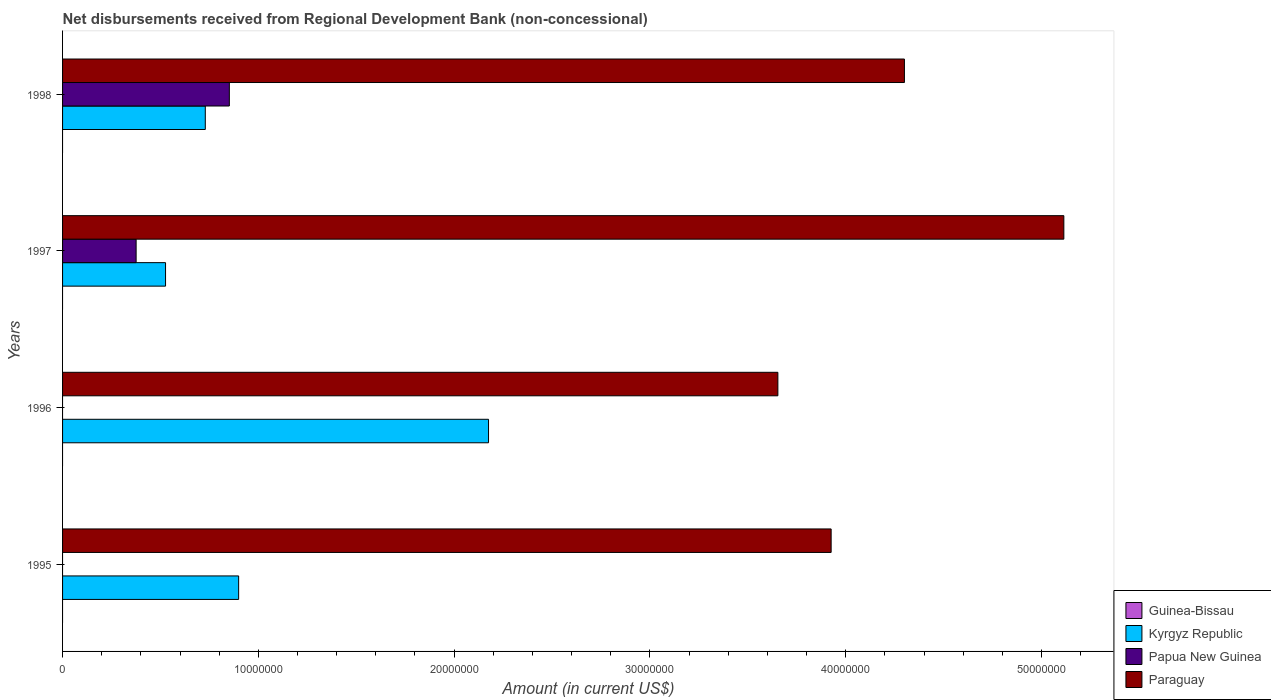How many groups of bars are there?
Ensure brevity in your answer.  4. Are the number of bars per tick equal to the number of legend labels?
Your answer should be very brief. No. In how many cases, is the number of bars for a given year not equal to the number of legend labels?
Your response must be concise. 4. What is the amount of disbursements received from Regional Development Bank in Guinea-Bissau in 1996?
Make the answer very short. 0. Across all years, what is the maximum amount of disbursements received from Regional Development Bank in Paraguay?
Provide a short and direct response. 5.11e+07. Across all years, what is the minimum amount of disbursements received from Regional Development Bank in Kyrgyz Republic?
Offer a very short reply. 5.26e+06. In which year was the amount of disbursements received from Regional Development Bank in Kyrgyz Republic maximum?
Your response must be concise. 1996. What is the total amount of disbursements received from Regional Development Bank in Kyrgyz Republic in the graph?
Provide a short and direct response. 4.33e+07. What is the difference between the amount of disbursements received from Regional Development Bank in Paraguay in 1995 and that in 1997?
Make the answer very short. -1.19e+07. What is the difference between the amount of disbursements received from Regional Development Bank in Paraguay in 1998 and the amount of disbursements received from Regional Development Bank in Papua New Guinea in 1997?
Provide a succinct answer. 3.92e+07. In the year 1997, what is the difference between the amount of disbursements received from Regional Development Bank in Papua New Guinea and amount of disbursements received from Regional Development Bank in Paraguay?
Offer a very short reply. -4.74e+07. In how many years, is the amount of disbursements received from Regional Development Bank in Kyrgyz Republic greater than 12000000 US$?
Offer a terse response. 1. What is the ratio of the amount of disbursements received from Regional Development Bank in Paraguay in 1996 to that in 1998?
Your answer should be very brief. 0.85. Is the amount of disbursements received from Regional Development Bank in Kyrgyz Republic in 1996 less than that in 1998?
Make the answer very short. No. What is the difference between the highest and the second highest amount of disbursements received from Regional Development Bank in Paraguay?
Give a very brief answer. 8.14e+06. What is the difference between the highest and the lowest amount of disbursements received from Regional Development Bank in Paraguay?
Keep it short and to the point. 1.46e+07. Is the sum of the amount of disbursements received from Regional Development Bank in Papua New Guinea in 1997 and 1998 greater than the maximum amount of disbursements received from Regional Development Bank in Guinea-Bissau across all years?
Offer a very short reply. Yes. Is it the case that in every year, the sum of the amount of disbursements received from Regional Development Bank in Papua New Guinea and amount of disbursements received from Regional Development Bank in Guinea-Bissau is greater than the sum of amount of disbursements received from Regional Development Bank in Kyrgyz Republic and amount of disbursements received from Regional Development Bank in Paraguay?
Offer a very short reply. No. How many bars are there?
Ensure brevity in your answer.  10. Are the values on the major ticks of X-axis written in scientific E-notation?
Provide a succinct answer. No. Does the graph contain any zero values?
Offer a terse response. Yes. Does the graph contain grids?
Your answer should be very brief. No. How are the legend labels stacked?
Make the answer very short. Vertical. What is the title of the graph?
Your answer should be compact. Net disbursements received from Regional Development Bank (non-concessional). Does "Guinea" appear as one of the legend labels in the graph?
Provide a succinct answer. No. What is the Amount (in current US$) of Kyrgyz Republic in 1995?
Give a very brief answer. 8.99e+06. What is the Amount (in current US$) of Paraguay in 1995?
Offer a terse response. 3.93e+07. What is the Amount (in current US$) in Guinea-Bissau in 1996?
Provide a succinct answer. 0. What is the Amount (in current US$) in Kyrgyz Republic in 1996?
Make the answer very short. 2.18e+07. What is the Amount (in current US$) of Paraguay in 1996?
Offer a terse response. 3.65e+07. What is the Amount (in current US$) in Kyrgyz Republic in 1997?
Make the answer very short. 5.26e+06. What is the Amount (in current US$) in Papua New Guinea in 1997?
Offer a terse response. 3.76e+06. What is the Amount (in current US$) in Paraguay in 1997?
Your response must be concise. 5.11e+07. What is the Amount (in current US$) in Kyrgyz Republic in 1998?
Provide a succinct answer. 7.29e+06. What is the Amount (in current US$) in Papua New Guinea in 1998?
Your answer should be compact. 8.52e+06. What is the Amount (in current US$) in Paraguay in 1998?
Provide a succinct answer. 4.30e+07. Across all years, what is the maximum Amount (in current US$) in Kyrgyz Republic?
Provide a succinct answer. 2.18e+07. Across all years, what is the maximum Amount (in current US$) in Papua New Guinea?
Provide a succinct answer. 8.52e+06. Across all years, what is the maximum Amount (in current US$) in Paraguay?
Your answer should be very brief. 5.11e+07. Across all years, what is the minimum Amount (in current US$) in Kyrgyz Republic?
Provide a short and direct response. 5.26e+06. Across all years, what is the minimum Amount (in current US$) in Paraguay?
Offer a very short reply. 3.65e+07. What is the total Amount (in current US$) in Kyrgyz Republic in the graph?
Offer a very short reply. 4.33e+07. What is the total Amount (in current US$) of Papua New Guinea in the graph?
Provide a short and direct response. 1.23e+07. What is the total Amount (in current US$) of Paraguay in the graph?
Ensure brevity in your answer.  1.70e+08. What is the difference between the Amount (in current US$) in Kyrgyz Republic in 1995 and that in 1996?
Provide a short and direct response. -1.28e+07. What is the difference between the Amount (in current US$) of Paraguay in 1995 and that in 1996?
Ensure brevity in your answer.  2.72e+06. What is the difference between the Amount (in current US$) in Kyrgyz Republic in 1995 and that in 1997?
Your answer should be compact. 3.73e+06. What is the difference between the Amount (in current US$) of Paraguay in 1995 and that in 1997?
Give a very brief answer. -1.19e+07. What is the difference between the Amount (in current US$) of Kyrgyz Republic in 1995 and that in 1998?
Make the answer very short. 1.70e+06. What is the difference between the Amount (in current US$) of Paraguay in 1995 and that in 1998?
Make the answer very short. -3.74e+06. What is the difference between the Amount (in current US$) in Kyrgyz Republic in 1996 and that in 1997?
Keep it short and to the point. 1.65e+07. What is the difference between the Amount (in current US$) of Paraguay in 1996 and that in 1997?
Provide a succinct answer. -1.46e+07. What is the difference between the Amount (in current US$) in Kyrgyz Republic in 1996 and that in 1998?
Give a very brief answer. 1.45e+07. What is the difference between the Amount (in current US$) in Paraguay in 1996 and that in 1998?
Your answer should be very brief. -6.46e+06. What is the difference between the Amount (in current US$) of Kyrgyz Republic in 1997 and that in 1998?
Your response must be concise. -2.03e+06. What is the difference between the Amount (in current US$) in Papua New Guinea in 1997 and that in 1998?
Keep it short and to the point. -4.76e+06. What is the difference between the Amount (in current US$) in Paraguay in 1997 and that in 1998?
Your answer should be very brief. 8.14e+06. What is the difference between the Amount (in current US$) in Kyrgyz Republic in 1995 and the Amount (in current US$) in Paraguay in 1996?
Offer a terse response. -2.75e+07. What is the difference between the Amount (in current US$) in Kyrgyz Republic in 1995 and the Amount (in current US$) in Papua New Guinea in 1997?
Make the answer very short. 5.24e+06. What is the difference between the Amount (in current US$) in Kyrgyz Republic in 1995 and the Amount (in current US$) in Paraguay in 1997?
Your response must be concise. -4.21e+07. What is the difference between the Amount (in current US$) of Kyrgyz Republic in 1995 and the Amount (in current US$) of Papua New Guinea in 1998?
Offer a terse response. 4.75e+05. What is the difference between the Amount (in current US$) in Kyrgyz Republic in 1995 and the Amount (in current US$) in Paraguay in 1998?
Your response must be concise. -3.40e+07. What is the difference between the Amount (in current US$) in Kyrgyz Republic in 1996 and the Amount (in current US$) in Papua New Guinea in 1997?
Your response must be concise. 1.80e+07. What is the difference between the Amount (in current US$) in Kyrgyz Republic in 1996 and the Amount (in current US$) in Paraguay in 1997?
Your answer should be very brief. -2.94e+07. What is the difference between the Amount (in current US$) in Kyrgyz Republic in 1996 and the Amount (in current US$) in Papua New Guinea in 1998?
Your answer should be very brief. 1.32e+07. What is the difference between the Amount (in current US$) in Kyrgyz Republic in 1996 and the Amount (in current US$) in Paraguay in 1998?
Make the answer very short. -2.12e+07. What is the difference between the Amount (in current US$) of Kyrgyz Republic in 1997 and the Amount (in current US$) of Papua New Guinea in 1998?
Provide a succinct answer. -3.26e+06. What is the difference between the Amount (in current US$) of Kyrgyz Republic in 1997 and the Amount (in current US$) of Paraguay in 1998?
Give a very brief answer. -3.77e+07. What is the difference between the Amount (in current US$) of Papua New Guinea in 1997 and the Amount (in current US$) of Paraguay in 1998?
Offer a very short reply. -3.92e+07. What is the average Amount (in current US$) of Kyrgyz Republic per year?
Keep it short and to the point. 1.08e+07. What is the average Amount (in current US$) of Papua New Guinea per year?
Your answer should be very brief. 3.07e+06. What is the average Amount (in current US$) in Paraguay per year?
Make the answer very short. 4.25e+07. In the year 1995, what is the difference between the Amount (in current US$) of Kyrgyz Republic and Amount (in current US$) of Paraguay?
Keep it short and to the point. -3.03e+07. In the year 1996, what is the difference between the Amount (in current US$) of Kyrgyz Republic and Amount (in current US$) of Paraguay?
Offer a terse response. -1.48e+07. In the year 1997, what is the difference between the Amount (in current US$) in Kyrgyz Republic and Amount (in current US$) in Papua New Guinea?
Offer a terse response. 1.50e+06. In the year 1997, what is the difference between the Amount (in current US$) of Kyrgyz Republic and Amount (in current US$) of Paraguay?
Offer a very short reply. -4.59e+07. In the year 1997, what is the difference between the Amount (in current US$) of Papua New Guinea and Amount (in current US$) of Paraguay?
Keep it short and to the point. -4.74e+07. In the year 1998, what is the difference between the Amount (in current US$) in Kyrgyz Republic and Amount (in current US$) in Papua New Guinea?
Give a very brief answer. -1.23e+06. In the year 1998, what is the difference between the Amount (in current US$) of Kyrgyz Republic and Amount (in current US$) of Paraguay?
Offer a terse response. -3.57e+07. In the year 1998, what is the difference between the Amount (in current US$) of Papua New Guinea and Amount (in current US$) of Paraguay?
Your answer should be very brief. -3.45e+07. What is the ratio of the Amount (in current US$) in Kyrgyz Republic in 1995 to that in 1996?
Offer a terse response. 0.41. What is the ratio of the Amount (in current US$) of Paraguay in 1995 to that in 1996?
Provide a succinct answer. 1.07. What is the ratio of the Amount (in current US$) in Kyrgyz Republic in 1995 to that in 1997?
Provide a succinct answer. 1.71. What is the ratio of the Amount (in current US$) in Paraguay in 1995 to that in 1997?
Offer a terse response. 0.77. What is the ratio of the Amount (in current US$) in Kyrgyz Republic in 1995 to that in 1998?
Provide a succinct answer. 1.23. What is the ratio of the Amount (in current US$) in Paraguay in 1995 to that in 1998?
Your response must be concise. 0.91. What is the ratio of the Amount (in current US$) of Kyrgyz Republic in 1996 to that in 1997?
Your response must be concise. 4.14. What is the ratio of the Amount (in current US$) of Paraguay in 1996 to that in 1997?
Offer a very short reply. 0.71. What is the ratio of the Amount (in current US$) of Kyrgyz Republic in 1996 to that in 1998?
Ensure brevity in your answer.  2.98. What is the ratio of the Amount (in current US$) in Paraguay in 1996 to that in 1998?
Ensure brevity in your answer.  0.85. What is the ratio of the Amount (in current US$) of Kyrgyz Republic in 1997 to that in 1998?
Offer a terse response. 0.72. What is the ratio of the Amount (in current US$) of Papua New Guinea in 1997 to that in 1998?
Provide a succinct answer. 0.44. What is the ratio of the Amount (in current US$) in Paraguay in 1997 to that in 1998?
Provide a succinct answer. 1.19. What is the difference between the highest and the second highest Amount (in current US$) in Kyrgyz Republic?
Your answer should be very brief. 1.28e+07. What is the difference between the highest and the second highest Amount (in current US$) of Paraguay?
Keep it short and to the point. 8.14e+06. What is the difference between the highest and the lowest Amount (in current US$) of Kyrgyz Republic?
Offer a terse response. 1.65e+07. What is the difference between the highest and the lowest Amount (in current US$) of Papua New Guinea?
Your answer should be very brief. 8.52e+06. What is the difference between the highest and the lowest Amount (in current US$) of Paraguay?
Ensure brevity in your answer.  1.46e+07. 